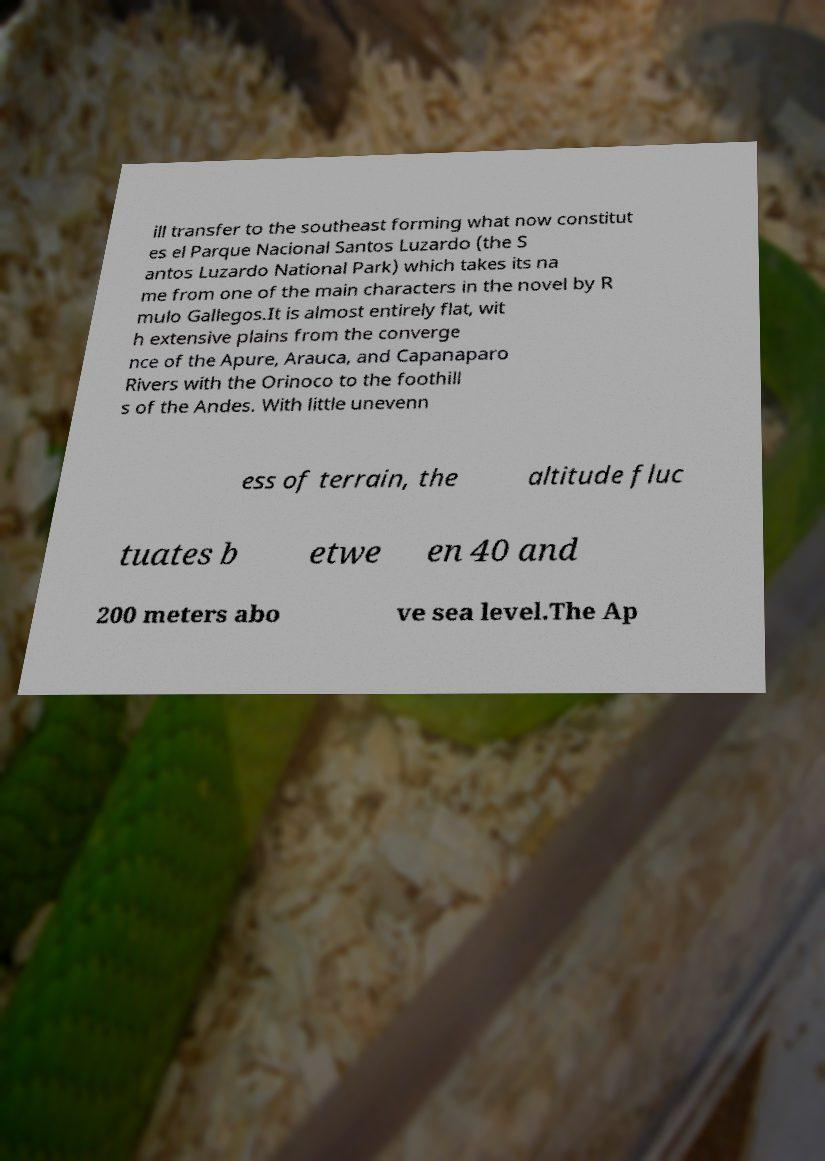What messages or text are displayed in this image? I need them in a readable, typed format. ill transfer to the southeast forming what now constitut es el Parque Nacional Santos Luzardo (the S antos Luzardo National Park) which takes its na me from one of the main characters in the novel by R mulo Gallegos.It is almost entirely flat, wit h extensive plains from the converge nce of the Apure, Arauca, and Capanaparo Rivers with the Orinoco to the foothill s of the Andes. With little unevenn ess of terrain, the altitude fluc tuates b etwe en 40 and 200 meters abo ve sea level.The Ap 